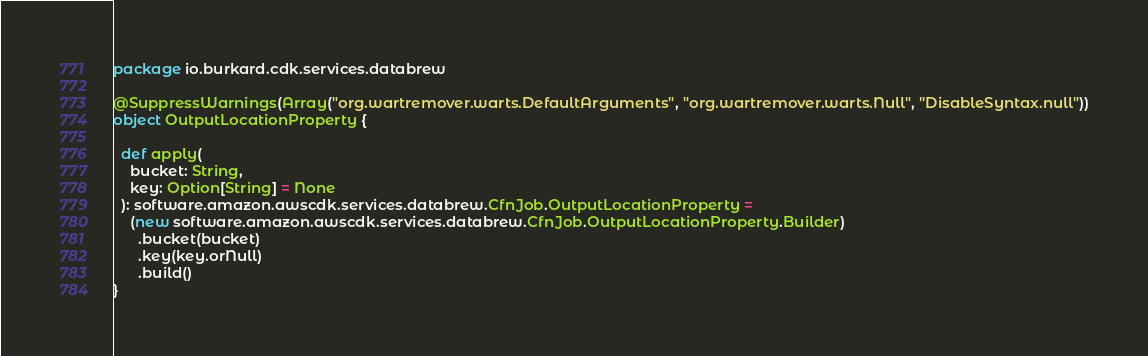Convert code to text. <code><loc_0><loc_0><loc_500><loc_500><_Scala_>package io.burkard.cdk.services.databrew

@SuppressWarnings(Array("org.wartremover.warts.DefaultArguments", "org.wartremover.warts.Null", "DisableSyntax.null"))
object OutputLocationProperty {

  def apply(
    bucket: String,
    key: Option[String] = None
  ): software.amazon.awscdk.services.databrew.CfnJob.OutputLocationProperty =
    (new software.amazon.awscdk.services.databrew.CfnJob.OutputLocationProperty.Builder)
      .bucket(bucket)
      .key(key.orNull)
      .build()
}
</code> 